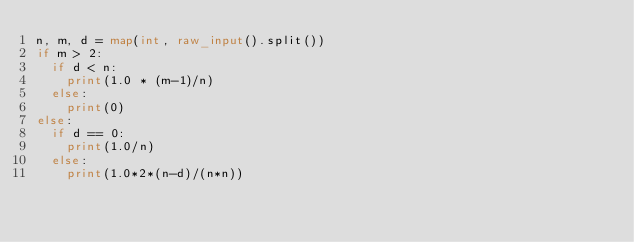<code> <loc_0><loc_0><loc_500><loc_500><_Python_>n, m, d = map(int, raw_input().split())
if m > 2:
  if d < n:
    print(1.0 * (m-1)/n)
  else:
    print(0)
else:
  if d == 0:
    print(1.0/n)
  else:
    print(1.0*2*(n-d)/(n*n))
</code> 